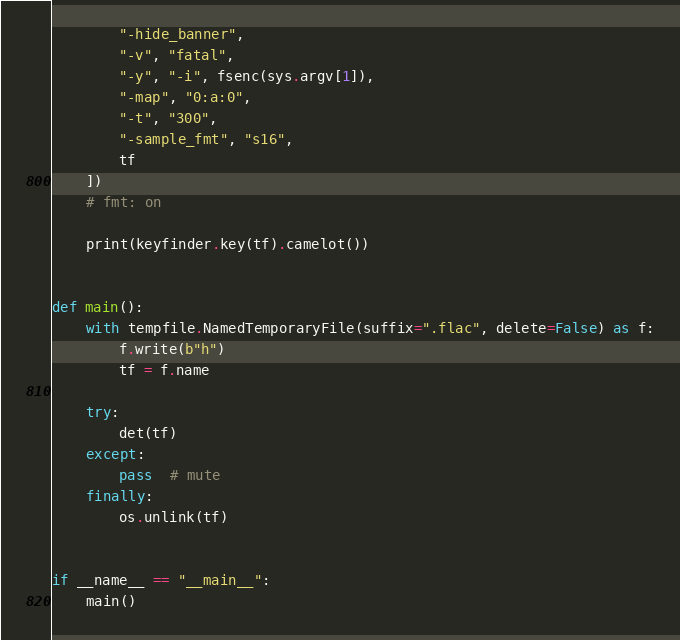<code> <loc_0><loc_0><loc_500><loc_500><_Python_>        "-hide_banner",
        "-v", "fatal",
        "-y", "-i", fsenc(sys.argv[1]),
        "-map", "0:a:0",
        "-t", "300",
        "-sample_fmt", "s16",
        tf
    ])
    # fmt: on

    print(keyfinder.key(tf).camelot())


def main():
    with tempfile.NamedTemporaryFile(suffix=".flac", delete=False) as f:
        f.write(b"h")
        tf = f.name

    try:
        det(tf)
    except:
        pass  # mute
    finally:
        os.unlink(tf)


if __name__ == "__main__":
    main()
</code> 